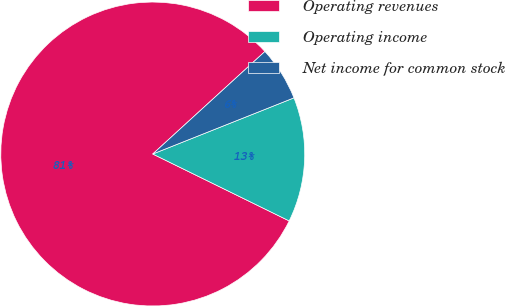<chart> <loc_0><loc_0><loc_500><loc_500><pie_chart><fcel>Operating revenues<fcel>Operating income<fcel>Net income for common stock<nl><fcel>80.96%<fcel>13.28%<fcel>5.76%<nl></chart> 